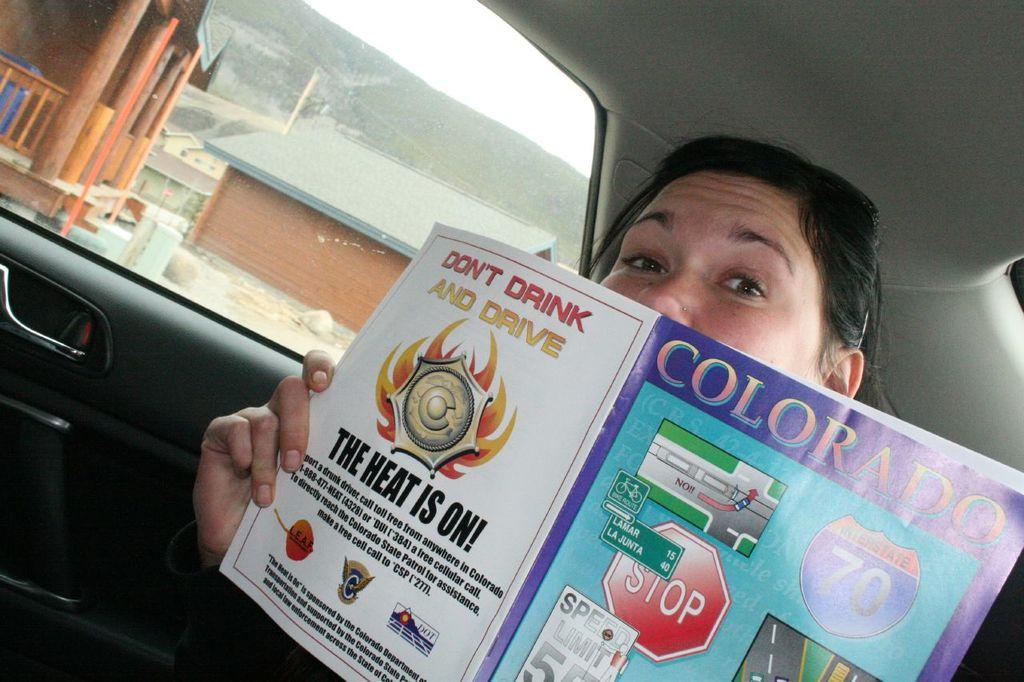What is the woman doing in the car? The woman is sitting in the car and hiding her face with a book. What can be seen outside the car window? There are houses visible outside the car window. Where are the houses located? The houses are located on mountains. What type of mint is growing near the houses on the mountains? There is no mention of mint or any plants in the image, so it cannot be determined if there is any mint growing near the houses. 